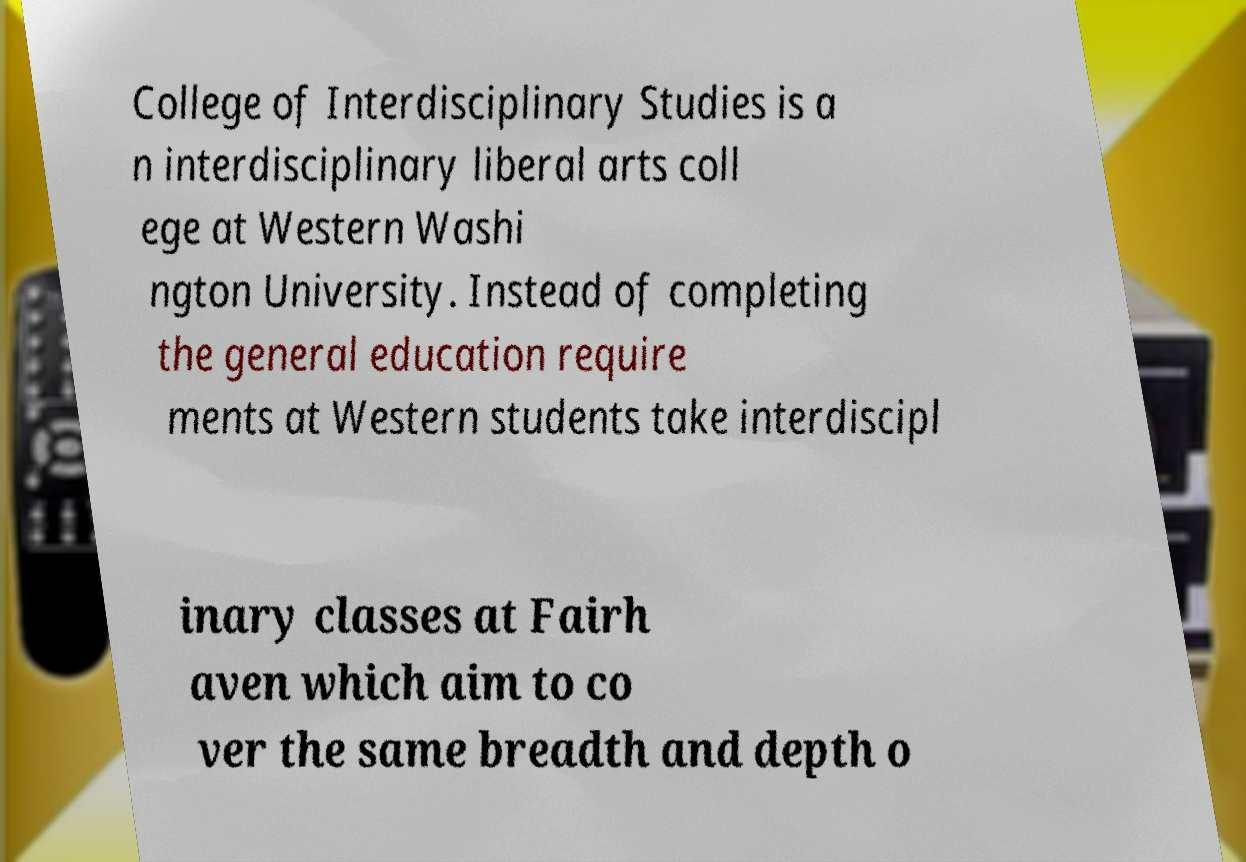I need the written content from this picture converted into text. Can you do that? College of Interdisciplinary Studies is a n interdisciplinary liberal arts coll ege at Western Washi ngton University. Instead of completing the general education require ments at Western students take interdiscipl inary classes at Fairh aven which aim to co ver the same breadth and depth o 